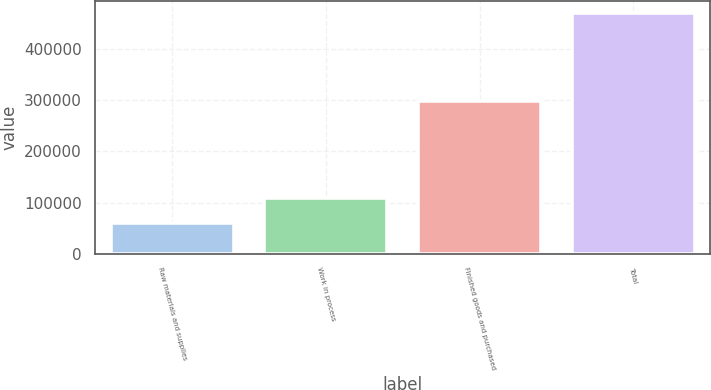<chart> <loc_0><loc_0><loc_500><loc_500><bar_chart><fcel>Raw materials and supplies<fcel>Work in process<fcel>Finished goods and purchased<fcel>Total<nl><fcel>60699<fcel>109924<fcel>299465<fcel>470088<nl></chart> 